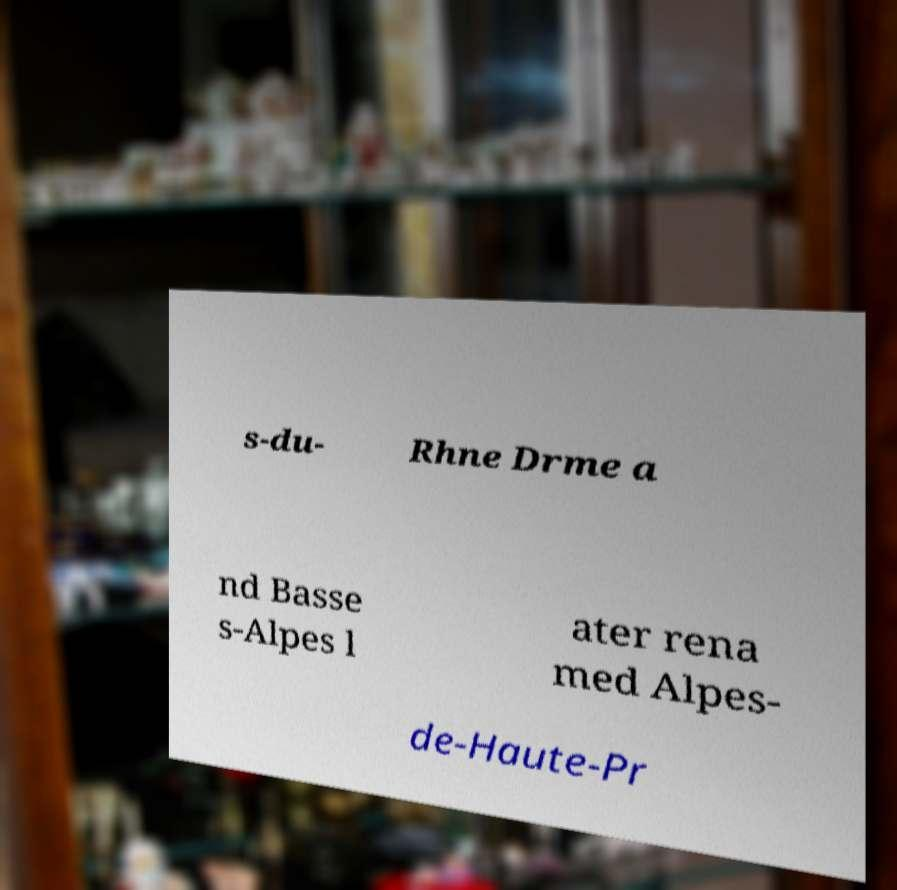Could you assist in decoding the text presented in this image and type it out clearly? s-du- Rhne Drme a nd Basse s-Alpes l ater rena med Alpes- de-Haute-Pr 